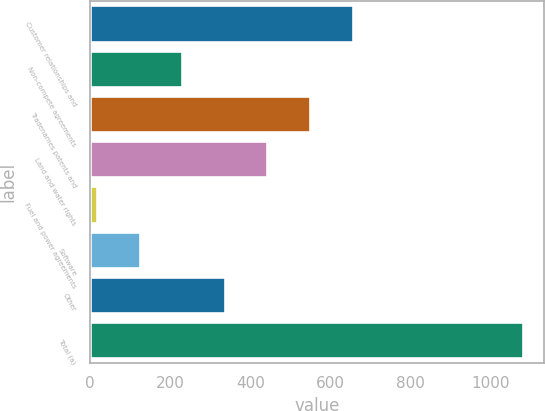Convert chart. <chart><loc_0><loc_0><loc_500><loc_500><bar_chart><fcel>Customer relationships and<fcel>Non-compete agreements<fcel>Tradenames patents and<fcel>Land and water rights<fcel>Fuel and power agreements<fcel>Software<fcel>Other<fcel>Total (a)<nl><fcel>654.8<fcel>229.6<fcel>548.5<fcel>442.2<fcel>17<fcel>123.3<fcel>335.9<fcel>1080<nl></chart> 